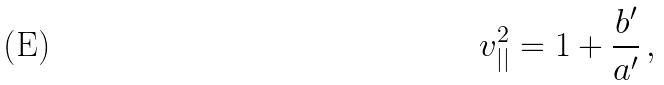<formula> <loc_0><loc_0><loc_500><loc_500>v _ { | | } ^ { 2 } = 1 + \frac { b ^ { \prime } } { a ^ { \prime } } \, ,</formula> 